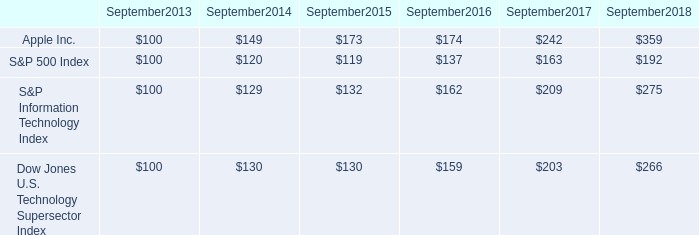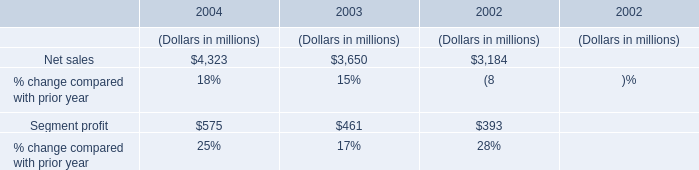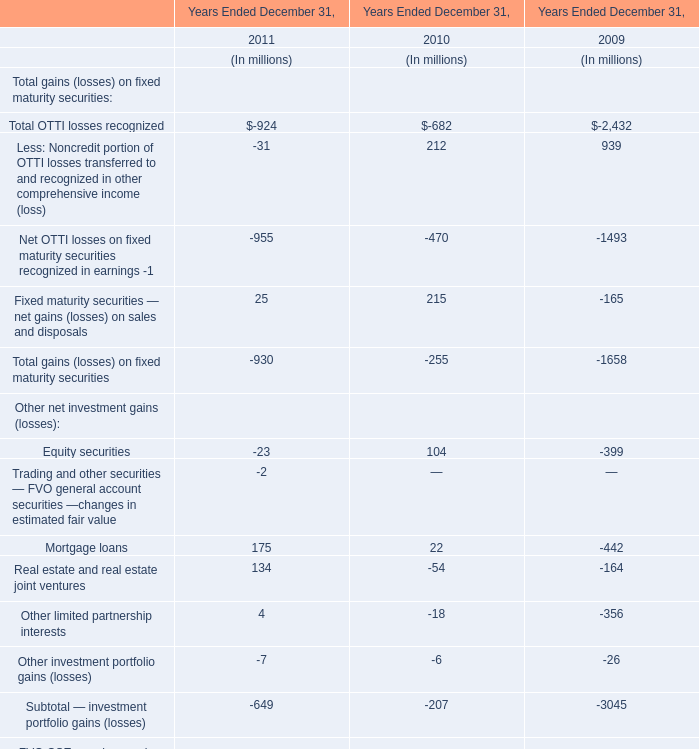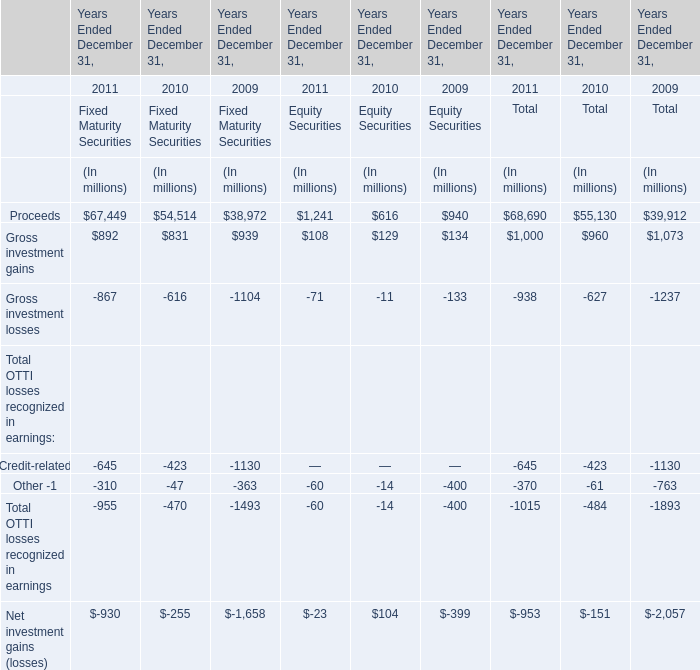What will Proceeds be like in 2012 if it develops with the same increasing rate as current? (in million) 
Computations: (68690 * (1 + ((68690 - 55130) / 55130)))
Answer: 85585.27299. 